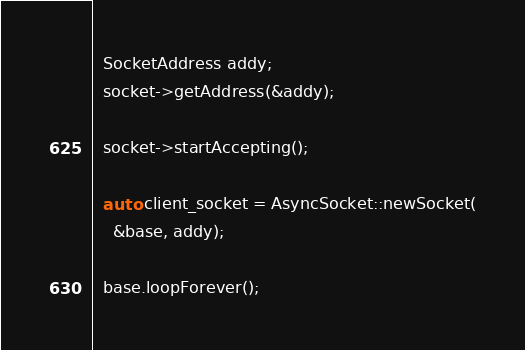Convert code to text. <code><loc_0><loc_0><loc_500><loc_500><_C++_>  SocketAddress addy;
  socket->getAddress(&addy);

  socket->startAccepting();

  auto client_socket = AsyncSocket::newSocket(
    &base, addy);

  base.loopForever();
</code> 